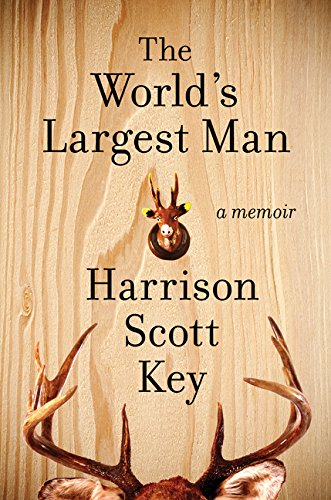Is this book related to Humor & Entertainment? Yes, this memoir is indeed related to Humor & Entertainment, attracting readers with its witty narrative and engaging storytelling. 